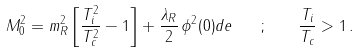Convert formula to latex. <formula><loc_0><loc_0><loc_500><loc_500>M ^ { 2 } _ { 0 } = m ^ { 2 } _ { R } \left [ \frac { T ^ { 2 } _ { i } } { T ^ { 2 } _ { c } } - 1 \right ] + \frac { \lambda _ { R } } { 2 } \, \phi ^ { 2 } ( 0 ) d e \quad ; \quad \frac { T _ { i } } { T _ { c } } > 1 \, .</formula> 